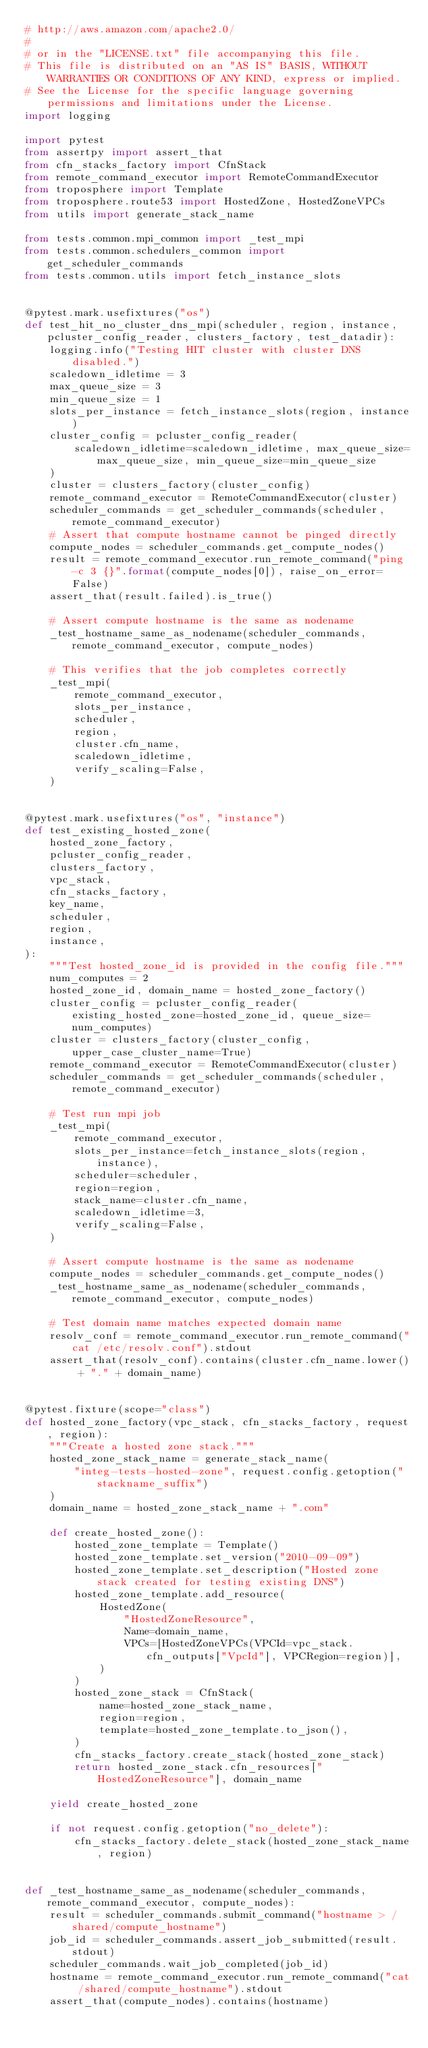<code> <loc_0><loc_0><loc_500><loc_500><_Python_># http://aws.amazon.com/apache2.0/
#
# or in the "LICENSE.txt" file accompanying this file.
# This file is distributed on an "AS IS" BASIS, WITHOUT WARRANTIES OR CONDITIONS OF ANY KIND, express or implied.
# See the License for the specific language governing permissions and limitations under the License.
import logging

import pytest
from assertpy import assert_that
from cfn_stacks_factory import CfnStack
from remote_command_executor import RemoteCommandExecutor
from troposphere import Template
from troposphere.route53 import HostedZone, HostedZoneVPCs
from utils import generate_stack_name

from tests.common.mpi_common import _test_mpi
from tests.common.schedulers_common import get_scheduler_commands
from tests.common.utils import fetch_instance_slots


@pytest.mark.usefixtures("os")
def test_hit_no_cluster_dns_mpi(scheduler, region, instance, pcluster_config_reader, clusters_factory, test_datadir):
    logging.info("Testing HIT cluster with cluster DNS disabled.")
    scaledown_idletime = 3
    max_queue_size = 3
    min_queue_size = 1
    slots_per_instance = fetch_instance_slots(region, instance)
    cluster_config = pcluster_config_reader(
        scaledown_idletime=scaledown_idletime, max_queue_size=max_queue_size, min_queue_size=min_queue_size
    )
    cluster = clusters_factory(cluster_config)
    remote_command_executor = RemoteCommandExecutor(cluster)
    scheduler_commands = get_scheduler_commands(scheduler, remote_command_executor)
    # Assert that compute hostname cannot be pinged directly
    compute_nodes = scheduler_commands.get_compute_nodes()
    result = remote_command_executor.run_remote_command("ping -c 3 {}".format(compute_nodes[0]), raise_on_error=False)
    assert_that(result.failed).is_true()

    # Assert compute hostname is the same as nodename
    _test_hostname_same_as_nodename(scheduler_commands, remote_command_executor, compute_nodes)

    # This verifies that the job completes correctly
    _test_mpi(
        remote_command_executor,
        slots_per_instance,
        scheduler,
        region,
        cluster.cfn_name,
        scaledown_idletime,
        verify_scaling=False,
    )


@pytest.mark.usefixtures("os", "instance")
def test_existing_hosted_zone(
    hosted_zone_factory,
    pcluster_config_reader,
    clusters_factory,
    vpc_stack,
    cfn_stacks_factory,
    key_name,
    scheduler,
    region,
    instance,
):
    """Test hosted_zone_id is provided in the config file."""
    num_computes = 2
    hosted_zone_id, domain_name = hosted_zone_factory()
    cluster_config = pcluster_config_reader(existing_hosted_zone=hosted_zone_id, queue_size=num_computes)
    cluster = clusters_factory(cluster_config, upper_case_cluster_name=True)
    remote_command_executor = RemoteCommandExecutor(cluster)
    scheduler_commands = get_scheduler_commands(scheduler, remote_command_executor)

    # Test run mpi job
    _test_mpi(
        remote_command_executor,
        slots_per_instance=fetch_instance_slots(region, instance),
        scheduler=scheduler,
        region=region,
        stack_name=cluster.cfn_name,
        scaledown_idletime=3,
        verify_scaling=False,
    )

    # Assert compute hostname is the same as nodename
    compute_nodes = scheduler_commands.get_compute_nodes()
    _test_hostname_same_as_nodename(scheduler_commands, remote_command_executor, compute_nodes)

    # Test domain name matches expected domain name
    resolv_conf = remote_command_executor.run_remote_command("cat /etc/resolv.conf").stdout
    assert_that(resolv_conf).contains(cluster.cfn_name.lower() + "." + domain_name)


@pytest.fixture(scope="class")
def hosted_zone_factory(vpc_stack, cfn_stacks_factory, request, region):
    """Create a hosted zone stack."""
    hosted_zone_stack_name = generate_stack_name(
        "integ-tests-hosted-zone", request.config.getoption("stackname_suffix")
    )
    domain_name = hosted_zone_stack_name + ".com"

    def create_hosted_zone():
        hosted_zone_template = Template()
        hosted_zone_template.set_version("2010-09-09")
        hosted_zone_template.set_description("Hosted zone stack created for testing existing DNS")
        hosted_zone_template.add_resource(
            HostedZone(
                "HostedZoneResource",
                Name=domain_name,
                VPCs=[HostedZoneVPCs(VPCId=vpc_stack.cfn_outputs["VpcId"], VPCRegion=region)],
            )
        )
        hosted_zone_stack = CfnStack(
            name=hosted_zone_stack_name,
            region=region,
            template=hosted_zone_template.to_json(),
        )
        cfn_stacks_factory.create_stack(hosted_zone_stack)
        return hosted_zone_stack.cfn_resources["HostedZoneResource"], domain_name

    yield create_hosted_zone

    if not request.config.getoption("no_delete"):
        cfn_stacks_factory.delete_stack(hosted_zone_stack_name, region)


def _test_hostname_same_as_nodename(scheduler_commands, remote_command_executor, compute_nodes):
    result = scheduler_commands.submit_command("hostname > /shared/compute_hostname")
    job_id = scheduler_commands.assert_job_submitted(result.stdout)
    scheduler_commands.wait_job_completed(job_id)
    hostname = remote_command_executor.run_remote_command("cat /shared/compute_hostname").stdout
    assert_that(compute_nodes).contains(hostname)
</code> 